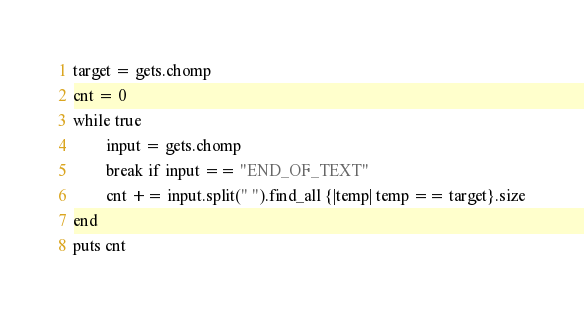Convert code to text. <code><loc_0><loc_0><loc_500><loc_500><_Ruby_>target = gets.chomp
cnt = 0
while true
        input = gets.chomp
        break if input == "END_OF_TEXT"
        cnt += input.split(" ").find_all {|temp| temp == target}.size
end
puts cnt</code> 